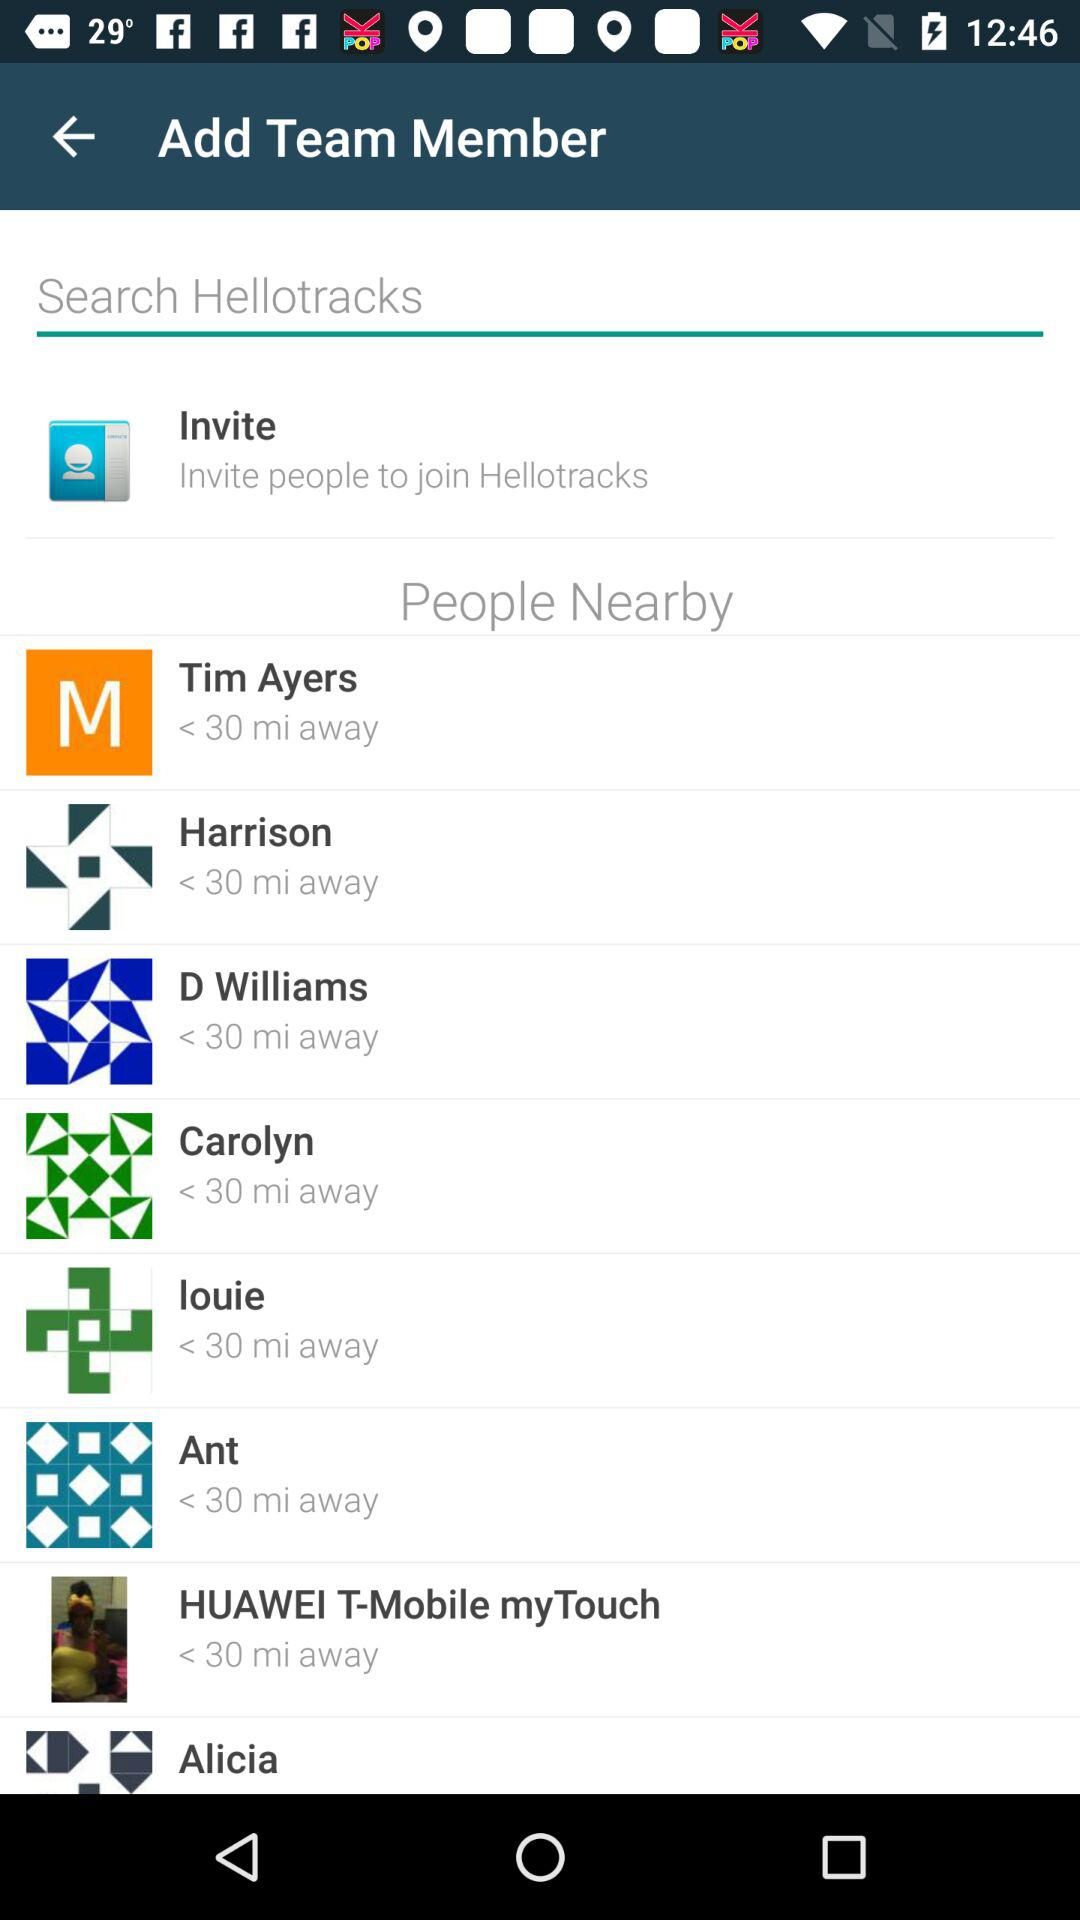How far away is D Williams from you? D Williams is 30 miles away from you. 